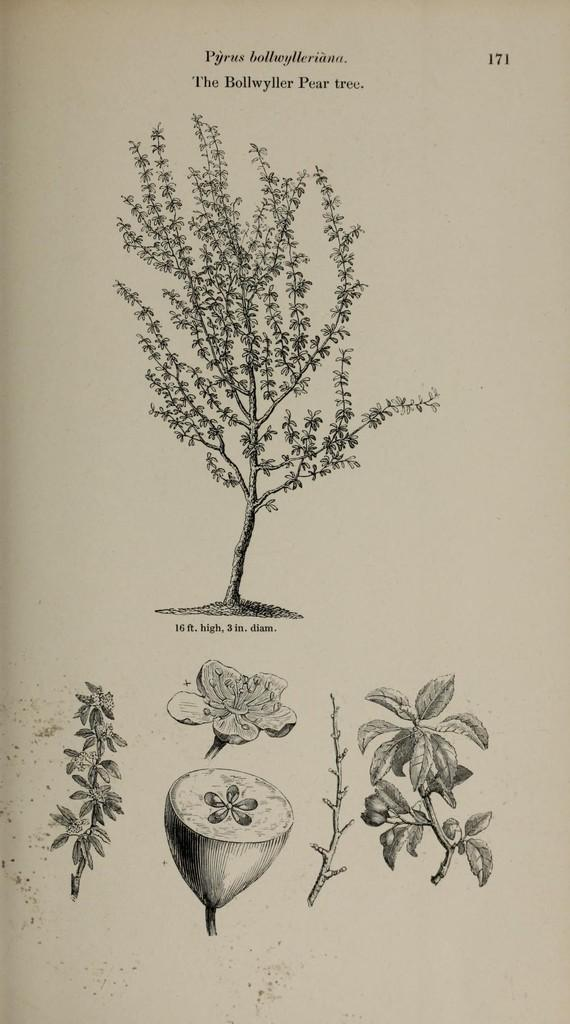What is the main subject of the image? The main subject of the image is a page. What can be found on the page? The page contains parts of a plant. What type of net is visible in the image? There is no net present in the image; it features a page with parts of a plant. What board is being used to display the plant parts in the image? There is no board present in the image; it features a page with parts of a plant. 